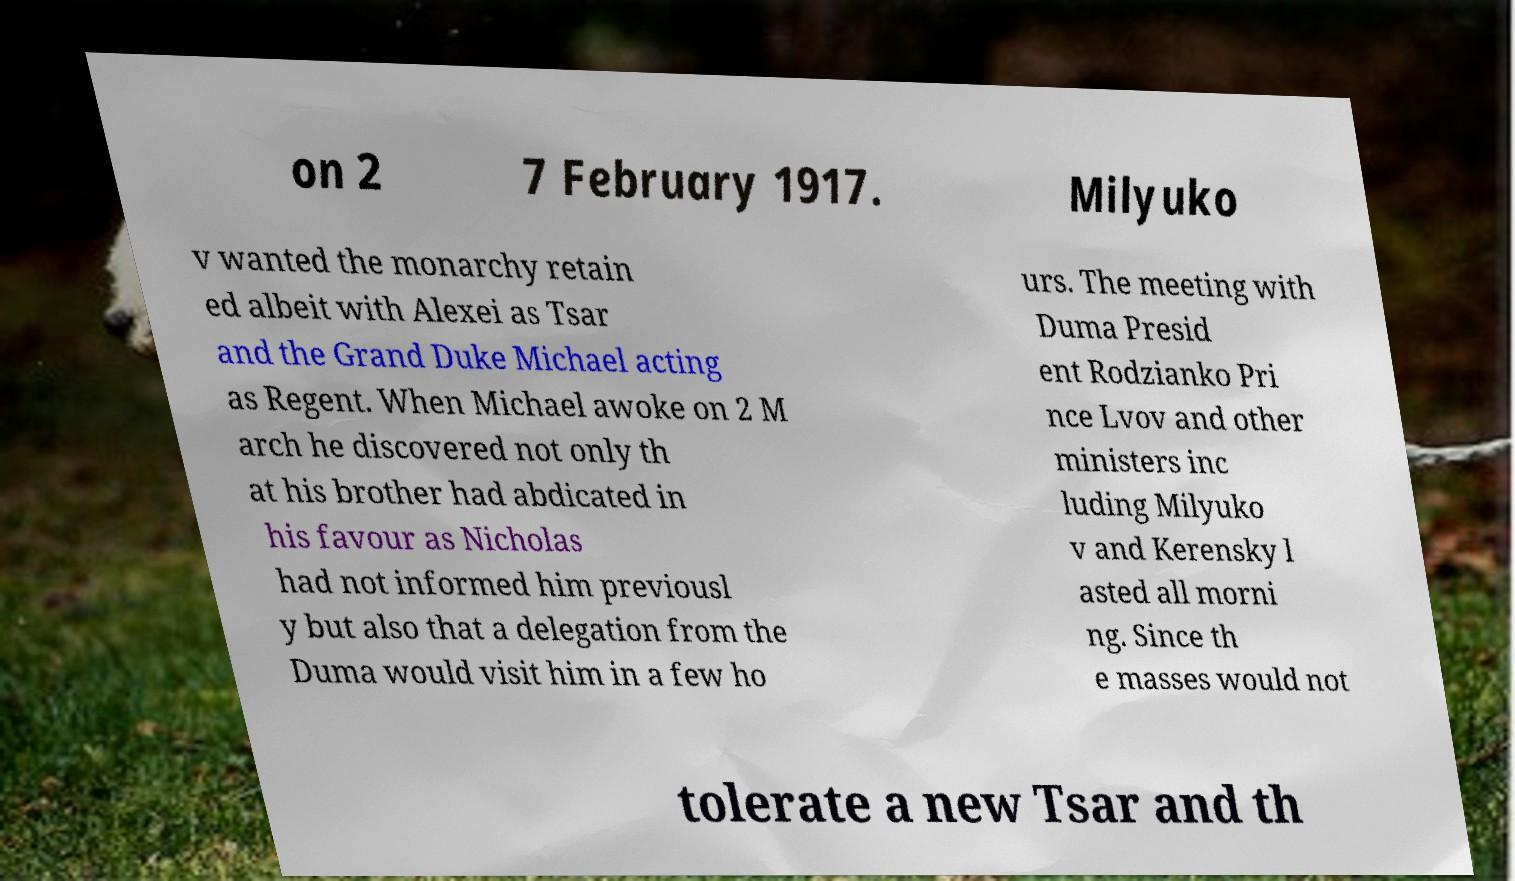Please read and relay the text visible in this image. What does it say? on 2 7 February 1917. Milyuko v wanted the monarchy retain ed albeit with Alexei as Tsar and the Grand Duke Michael acting as Regent. When Michael awoke on 2 M arch he discovered not only th at his brother had abdicated in his favour as Nicholas had not informed him previousl y but also that a delegation from the Duma would visit him in a few ho urs. The meeting with Duma Presid ent Rodzianko Pri nce Lvov and other ministers inc luding Milyuko v and Kerensky l asted all morni ng. Since th e masses would not tolerate a new Tsar and th 